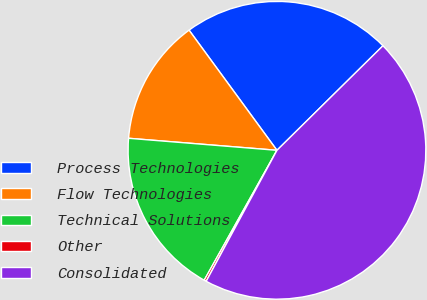<chart> <loc_0><loc_0><loc_500><loc_500><pie_chart><fcel>Process Technologies<fcel>Flow Technologies<fcel>Technical Solutions<fcel>Other<fcel>Consolidated<nl><fcel>22.66%<fcel>13.66%<fcel>18.16%<fcel>0.24%<fcel>45.27%<nl></chart> 